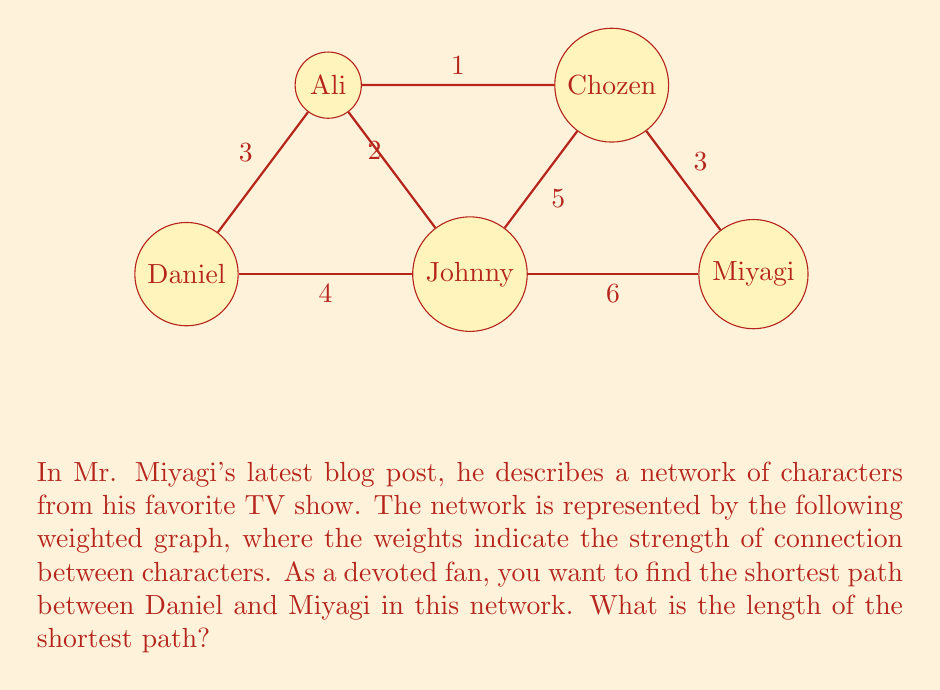What is the answer to this math problem? To solve this problem, we need to find the shortest path from Daniel to Miyagi in the given weighted graph. We can use Dijkstra's algorithm or simply examine all possible paths:

1. Daniel → Johnny → Miyagi
   Length: $4 + 6 = 10$

2. Daniel → Ali → Chozen → Miyagi
   Length: $3 + 1 + 3 = 7$

3. Daniel → Johnny → Chozen → Miyagi
   Length: $4 + 5 + 3 = 12$

4. Daniel → Ali → Johnny → Miyagi
   Length: $3 + 2 + 6 = 11$

The shortest path is Daniel → Ali → Chozen → Miyagi, with a total length of 7.

To verify this result mathematically, we can express the shortest path length as:

$$\min(\text{path lengths}) = \min(10, 7, 12, 11) = 7$$

This problem demonstrates the application of graph theory in analyzing character relationships, a topic Mr. Miyagi might appreciate given his wisdom in connecting with his students.
Answer: The length of the shortest path between Daniel and Miyagi is 7. 